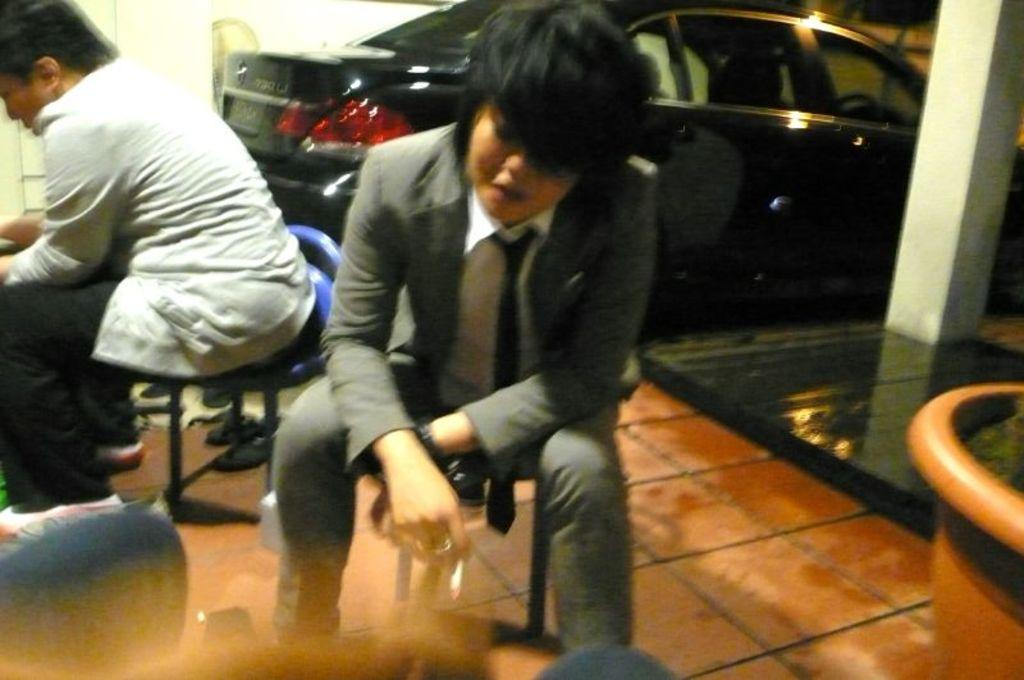How many people are in the image? There are two people in the image. What are the people doing in the image? The people are sitting on chairs. What can be seen in the background of the image? There is a car, a flower pot, and a walkway in the background of the image. Where is the sink located in the image? There is no sink present in the image. What type of camp can be seen in the background of the image? There is no camp present in the image. 